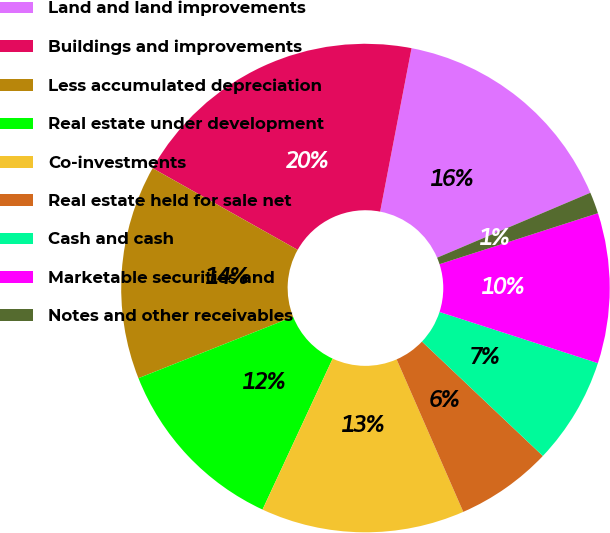<chart> <loc_0><loc_0><loc_500><loc_500><pie_chart><fcel>Land and land improvements<fcel>Buildings and improvements<fcel>Less accumulated depreciation<fcel>Real estate under development<fcel>Co-investments<fcel>Real estate held for sale net<fcel>Cash and cash<fcel>Marketable securities and<fcel>Notes and other receivables<nl><fcel>15.6%<fcel>19.86%<fcel>14.18%<fcel>12.06%<fcel>13.48%<fcel>6.38%<fcel>7.09%<fcel>9.93%<fcel>1.42%<nl></chart> 